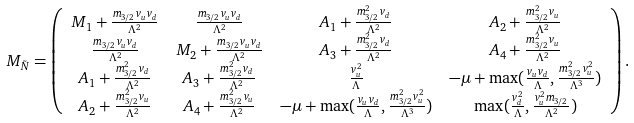<formula> <loc_0><loc_0><loc_500><loc_500>M _ { \tilde { N } } & = \left ( \begin{array} { c c c c } M _ { 1 } + \frac { m _ { 3 / 2 } v _ { u } v _ { d } } { \Lambda ^ { 2 } } & \frac { m _ { 3 / 2 } v _ { u } v _ { d } } { \Lambda ^ { 2 } } & A _ { 1 } + \frac { m _ { 3 / 2 } ^ { 2 } v _ { d } } { \Lambda ^ { 2 } } & A _ { 2 } + \frac { m _ { 3 / 2 } ^ { 2 } v _ { u } } { \Lambda ^ { 2 } } \\ \frac { m _ { 3 / 2 } v _ { u } v _ { d } } { \Lambda ^ { 2 } } & M _ { 2 } + \frac { m _ { 3 / 2 } v _ { u } v _ { d } } { \Lambda ^ { 2 } } & A _ { 3 } + \frac { m _ { 3 / 2 } ^ { 2 } v _ { d } } { \Lambda ^ { 2 } } & A _ { 4 } + \frac { m _ { 3 / 2 } ^ { 2 } v _ { u } } { \Lambda ^ { 2 } } \\ A _ { 1 } + \frac { m _ { 3 / 2 } ^ { 2 } v _ { d } } { \Lambda ^ { 2 } } & A _ { 3 } + \frac { m _ { 3 / 2 } ^ { 2 } v _ { d } } { \Lambda ^ { 2 } } & \frac { v _ { u } ^ { 2 } } { \Lambda } & - \mu + \max ( \frac { v _ { u } v _ { d } } { \Lambda } , \frac { m _ { 3 / 2 } ^ { 2 } v _ { u } ^ { 2 } } { \Lambda ^ { 3 } } ) \\ A _ { 2 } + \frac { m _ { 3 / 2 } ^ { 2 } v _ { u } } { \Lambda ^ { 2 } } & A _ { 4 } + \frac { m _ { 3 / 2 } ^ { 2 } v _ { u } } { \Lambda ^ { 2 } } & - \mu + \max ( \frac { v _ { u } v _ { d } } { \Lambda } , \frac { m _ { 3 / 2 } ^ { 2 } v _ { u } ^ { 2 } } { \Lambda ^ { 3 } } ) & \max ( \frac { v _ { d } ^ { 2 } } { \Lambda } , \frac { v _ { u } ^ { 2 } m _ { 3 / 2 } } { \Lambda ^ { 2 } } ) \end{array} \right ) .</formula> 